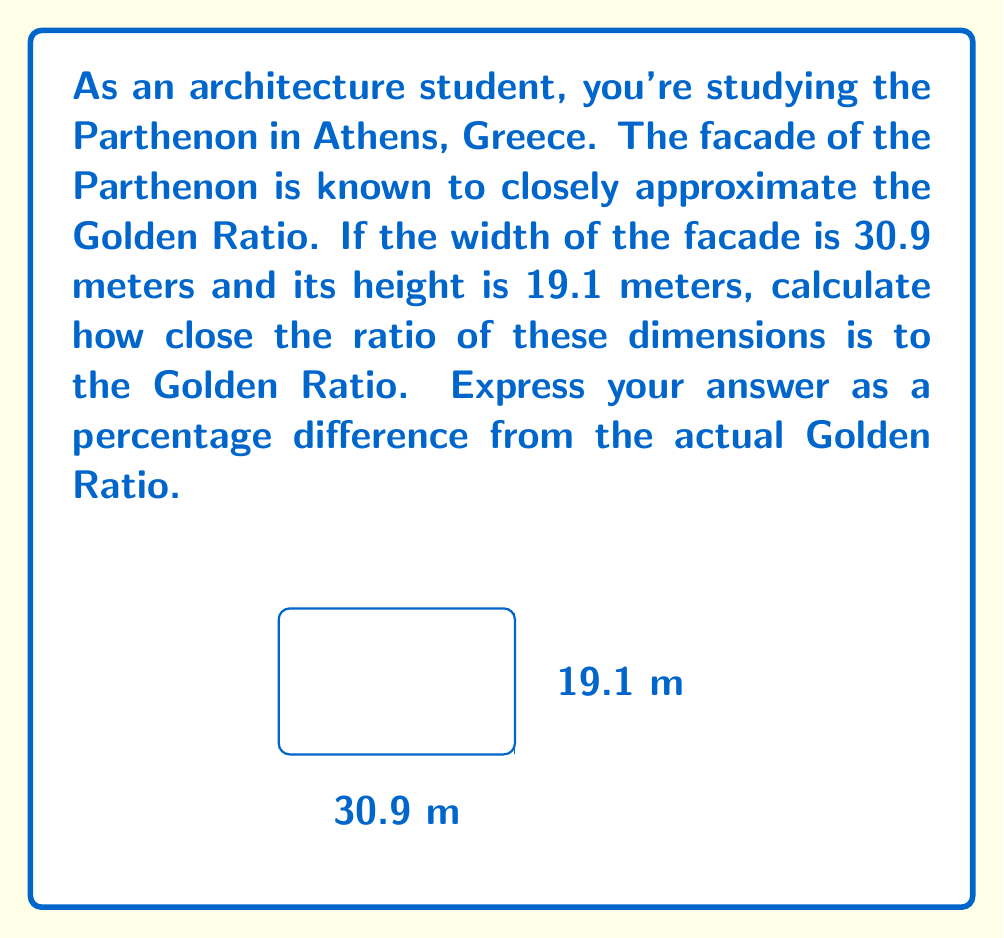What is the answer to this math problem? Let's approach this step-by-step:

1) The Golden Ratio, often denoted by φ (phi), is approximately equal to:
   $$\phi = \frac{1 + \sqrt{5}}{2} \approx 1.618033989$$

2) The ratio of the Parthenon's facade dimensions is:
   $$\text{Parthenon Ratio} = \frac{\text{Width}}{\text{Height}} = \frac{30.9}{19.1}$$

3) Let's calculate this ratio:
   $$\frac{30.9}{19.1} \approx 1.617801047$$

4) To find the percentage difference, we use the formula:
   $$\text{Percentage Difference} = \left|\frac{\text{Actual Value} - \text{Theoretical Value}}{\text{Theoretical Value}}\right| \times 100\%$$

5) Plugging in our values:
   $$\left|\frac{1.617801047 - 1.618033989}{1.618033989}\right| \times 100\%$$

6) Calculating:
   $$\approx 0.0143776\%$$

Thus, the Parthenon's facade ratio differs from the Golden Ratio by approximately 0.0144% (rounded to 4 decimal places).
Answer: 0.0144% 